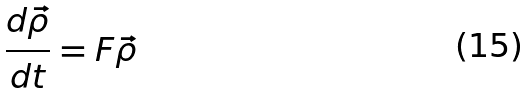Convert formula to latex. <formula><loc_0><loc_0><loc_500><loc_500>\frac { d \vec { \rho } } { d t } = F \vec { \rho }</formula> 